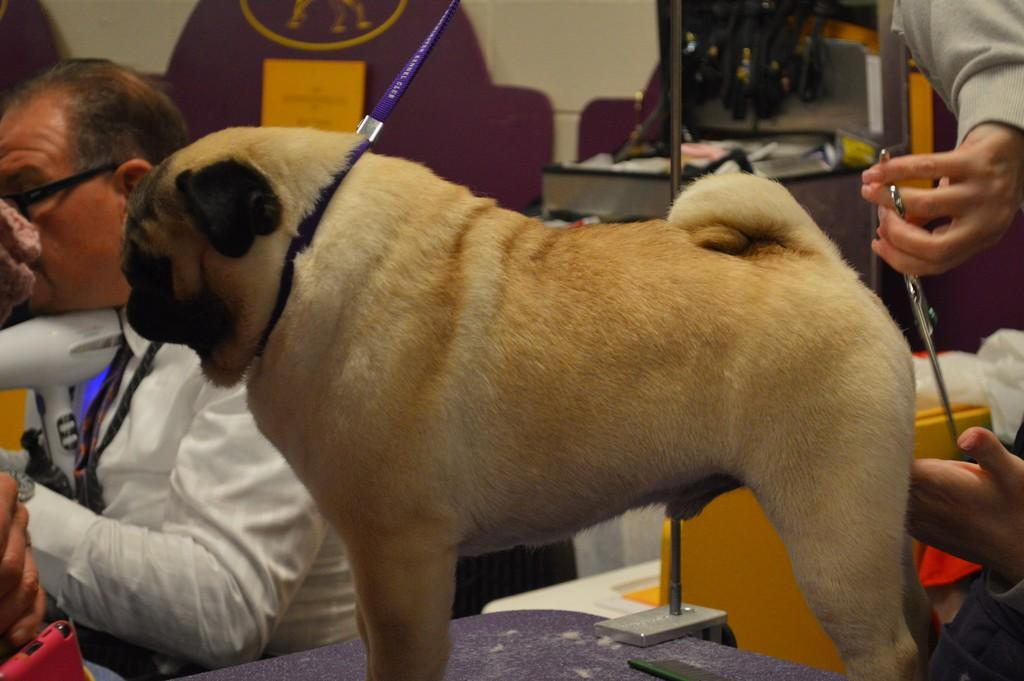What is the main subject of the image? The main subject of the image is a man. Can you describe the man's appearance? The man is wearing spectacles. What else can be seen in the image besides the man? There is a tag, a dog on a table with a chain attached to it, people's hands visible in the background, a wall, and a rod in the background. What title is the man holding in the image? There is no title present in the image; the man is not holding anything. What type of destruction can be seen in the image? There is no destruction present in the image; it features a man, a dog, and various objects in a seemingly undamaged environment. 